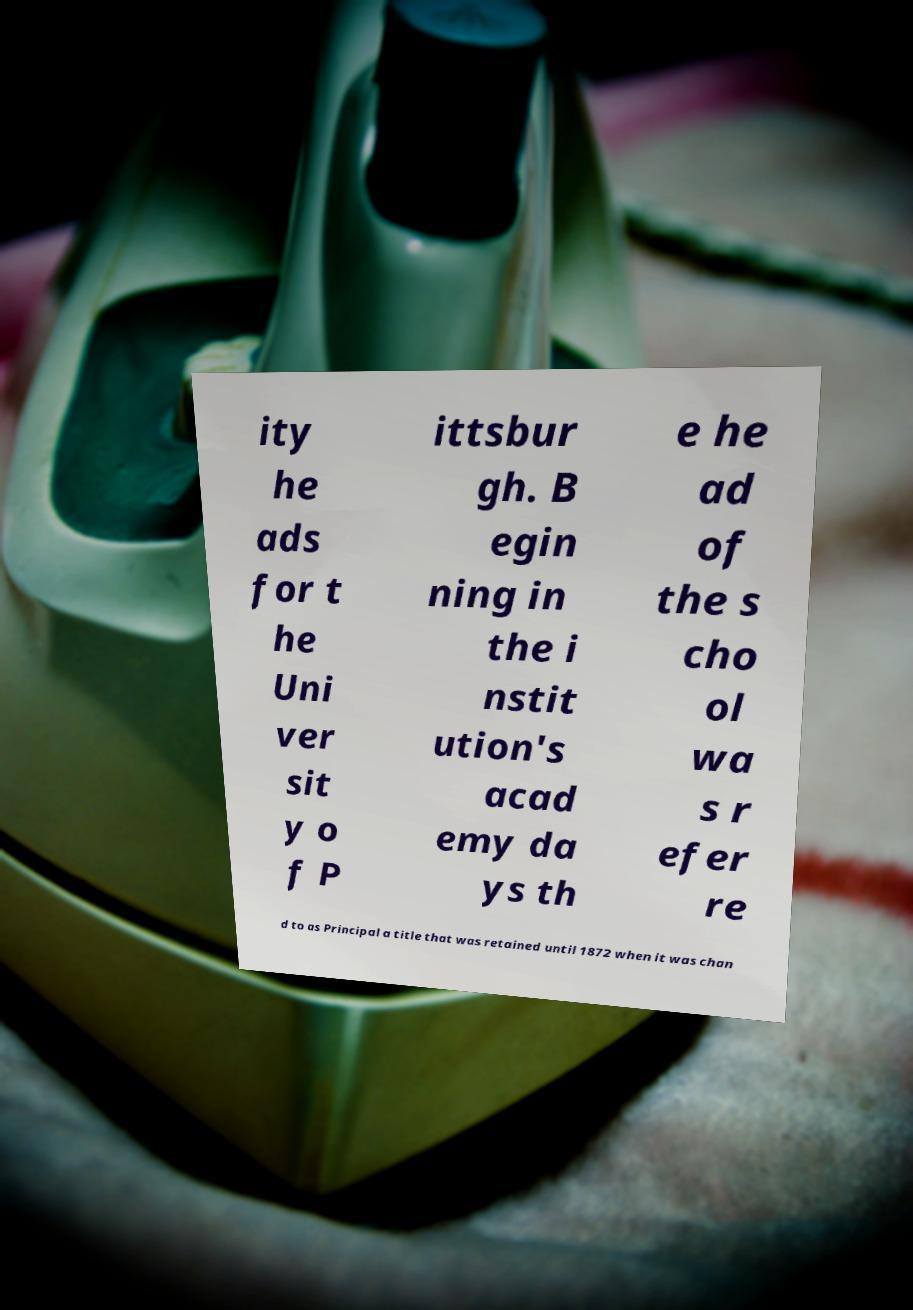Please read and relay the text visible in this image. What does it say? ity he ads for t he Uni ver sit y o f P ittsbur gh. B egin ning in the i nstit ution's acad emy da ys th e he ad of the s cho ol wa s r efer re d to as Principal a title that was retained until 1872 when it was chan 